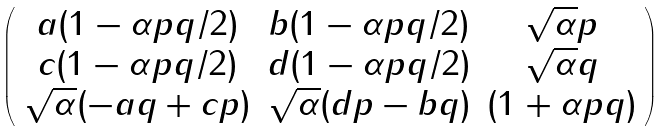Convert formula to latex. <formula><loc_0><loc_0><loc_500><loc_500>\left ( \begin{array} { c c c } a ( 1 - \alpha p q / 2 ) & b ( 1 - \alpha p q / 2 ) & \sqrt { \alpha } p \\ c ( 1 - \alpha p q / 2 ) & d ( 1 - \alpha p q / 2 ) & \sqrt { \alpha } q \\ \sqrt { \alpha } ( - a q + c p ) & \sqrt { \alpha } ( d p - b q ) & ( 1 + \alpha p q ) \end{array} \right )</formula> 